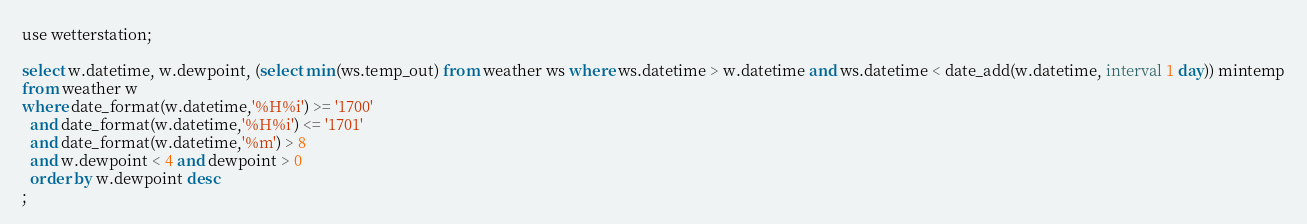Convert code to text. <code><loc_0><loc_0><loc_500><loc_500><_SQL_>use wetterstation;

select w.datetime, w.dewpoint, (select min(ws.temp_out) from weather ws where ws.datetime > w.datetime and ws.datetime < date_add(w.datetime, interval 1 day)) mintemp
from weather w
where date_format(w.datetime,'%H%i') >= '1700'
  and date_format(w.datetime,'%H%i') <= '1701'
  and date_format(w.datetime,'%m') > 8
  and w.dewpoint < 4 and dewpoint > 0
  order by w.dewpoint desc
;</code> 